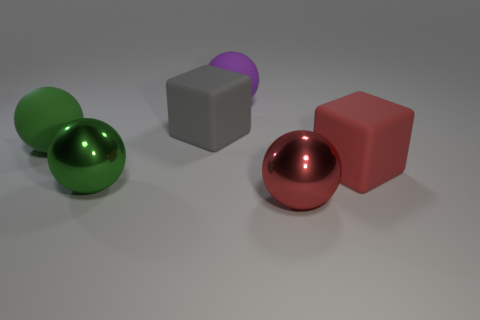Is the material of the big green sphere that is to the right of the green rubber sphere the same as the large red sphere?
Offer a very short reply. Yes. What number of objects are green matte objects or big metal balls that are on the left side of the purple ball?
Offer a very short reply. 2. What number of green matte things are behind the purple rubber ball that is behind the red thing that is to the right of the red metal object?
Your answer should be very brief. 0. There is a matte object that is in front of the green rubber ball; is its shape the same as the gray thing?
Provide a succinct answer. Yes. There is a metallic thing on the right side of the big purple object; are there any metal objects behind it?
Give a very brief answer. Yes. What number of large green matte blocks are there?
Keep it short and to the point. 0. What is the color of the matte object that is both in front of the big gray rubber cube and left of the red block?
Provide a short and direct response. Green. There is another rubber object that is the same shape as the big red matte object; what size is it?
Give a very brief answer. Large. What number of green metal balls have the same size as the purple rubber object?
Offer a terse response. 1. What is the red sphere made of?
Provide a short and direct response. Metal. 